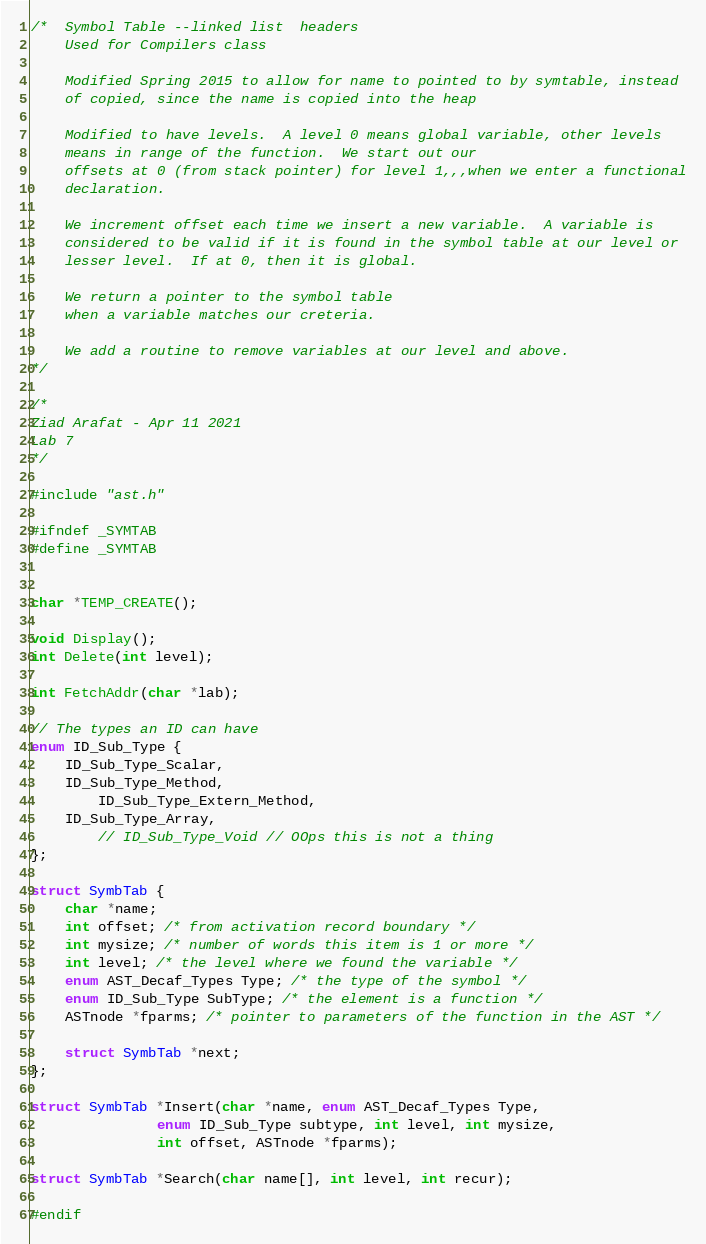Convert code to text. <code><loc_0><loc_0><loc_500><loc_500><_C_>/*  Symbol Table --linked list  headers
    Used for Compilers class

    Modified Spring 2015 to allow for name to pointed to by symtable, instead 
    of copied, since the name is copied into the heap

    Modified to have levels.  A level 0 means global variable, other levels
    means in range of the function.  We start out our
    offsets at 0 (from stack pointer) for level 1,,,when we enter a functional
    declaration.

    We increment offset each time we insert a new variable.  A variable is
    considered to be valid if it is found in the symbol table at our level or
    lesser level.  If at 0, then it is global.  

    We return a pointer to the symbol table
    when a variable matches our creteria.

    We add a routine to remove variables at our level and above.
*/

/*
Ziad Arafat - Apr 11 2021
Lab 7
*/

#include "ast.h"

#ifndef _SYMTAB
#define _SYMTAB


char *TEMP_CREATE();

void Display();
int Delete(int level);

int FetchAddr(char *lab);

// The types an ID can have
enum ID_Sub_Type {
	ID_Sub_Type_Scalar,
	ID_Sub_Type_Method,
        ID_Sub_Type_Extern_Method,
	ID_Sub_Type_Array,
        // ID_Sub_Type_Void // OOps this is not a thing
};

struct SymbTab {
	char *name;
	int offset; /* from activation record boundary */
	int mysize; /* number of words this item is 1 or more */
	int level; /* the level where we found the variable */
	enum AST_Decaf_Types Type; /* the type of the symbol */
	enum ID_Sub_Type SubType; /* the element is a function */
	ASTnode *fparms; /* pointer to parameters of the function in the AST */

	struct SymbTab *next;
};

struct SymbTab *Insert(char *name, enum AST_Decaf_Types Type,
		       enum ID_Sub_Type subtype, int level, int mysize,
		       int offset, ASTnode *fparms);

struct SymbTab *Search(char name[], int level, int recur);

#endif
</code> 